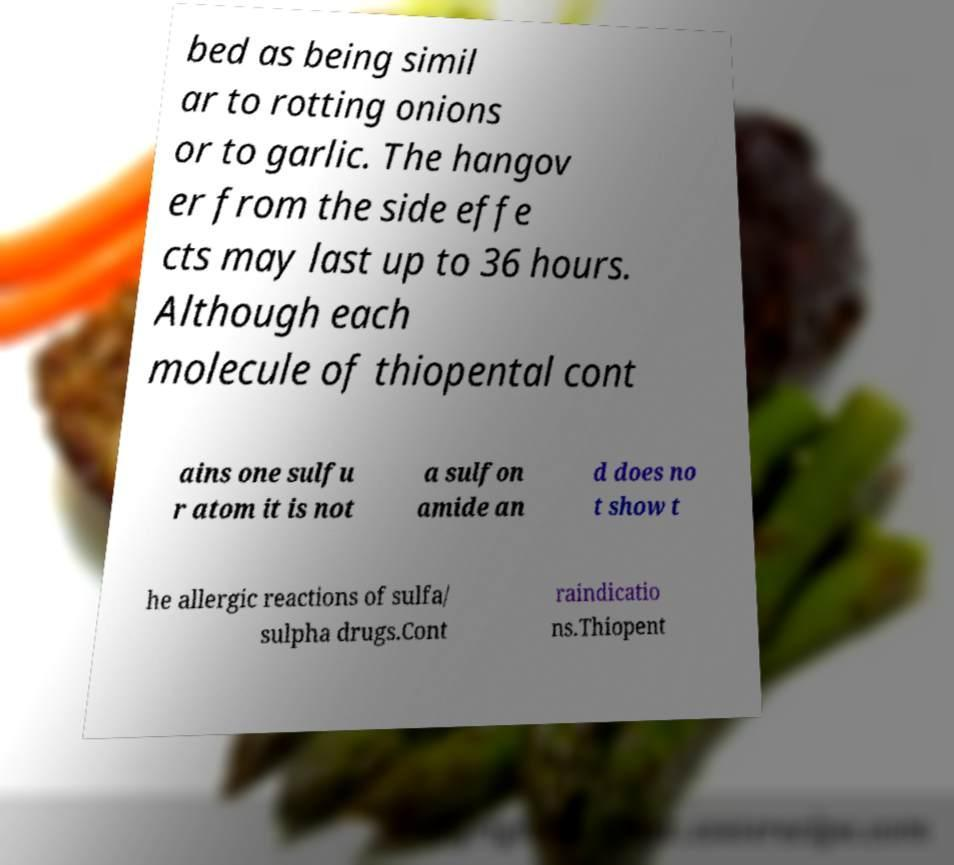What messages or text are displayed in this image? I need them in a readable, typed format. bed as being simil ar to rotting onions or to garlic. The hangov er from the side effe cts may last up to 36 hours. Although each molecule of thiopental cont ains one sulfu r atom it is not a sulfon amide an d does no t show t he allergic reactions of sulfa/ sulpha drugs.Cont raindicatio ns.Thiopent 